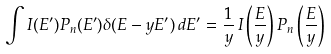<formula> <loc_0><loc_0><loc_500><loc_500>\int I ( E ^ { \prime } ) P _ { n } ( E ^ { \prime } ) \delta ( E - y E ^ { \prime } ) \, d E ^ { \prime } = \frac { 1 } { y } \, I \left ( \frac { E } { y } \right ) P _ { n } \left ( \frac { E } { y } \right )</formula> 